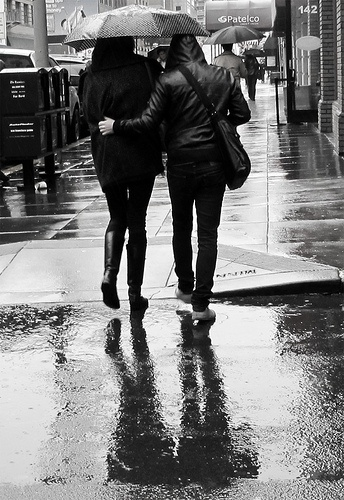Describe the objects in this image and their specific colors. I can see people in white, black, gray, and darkgray tones, people in white, black, gray, darkgray, and lightgray tones, umbrella in white, darkgray, lightgray, gray, and black tones, handbag in white, black, gray, and lightgray tones, and car in white, black, gray, and darkgray tones in this image. 